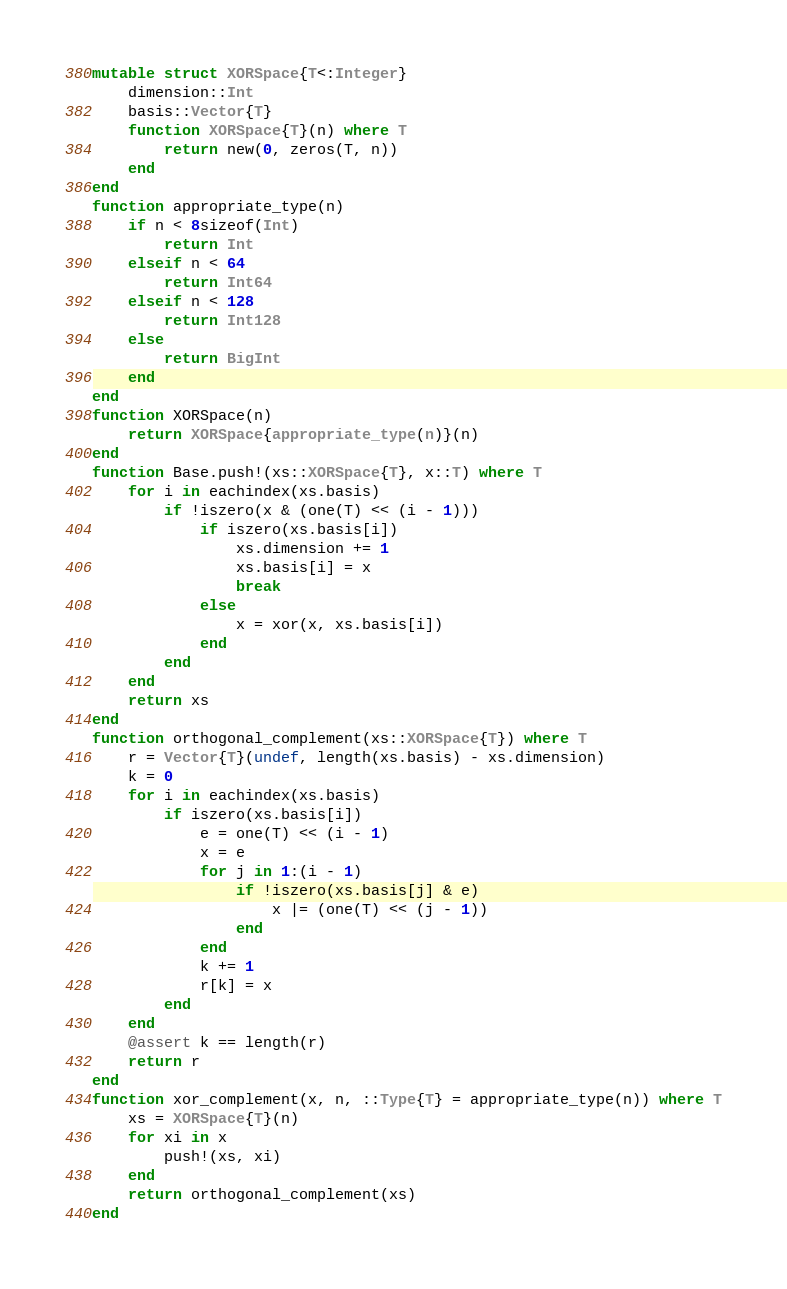<code> <loc_0><loc_0><loc_500><loc_500><_Julia_>mutable struct XORSpace{T<:Integer}
    dimension::Int
    basis::Vector{T}
    function XORSpace{T}(n) where T
        return new(0, zeros(T, n))
    end
end
function appropriate_type(n)
    if n < 8sizeof(Int)
        return Int
    elseif n < 64
        return Int64
    elseif n < 128
        return Int128
    else
        return BigInt
    end
end
function XORSpace(n)
    return XORSpace{appropriate_type(n)}(n)
end
function Base.push!(xs::XORSpace{T}, x::T) where T
    for i in eachindex(xs.basis)
        if !iszero(x & (one(T) << (i - 1)))
            if iszero(xs.basis[i])
                xs.dimension += 1
                xs.basis[i] = x
                break
            else
                x = xor(x, xs.basis[i])
            end
        end
    end
    return xs
end
function orthogonal_complement(xs::XORSpace{T}) where T
    r = Vector{T}(undef, length(xs.basis) - xs.dimension)
    k = 0
    for i in eachindex(xs.basis)
        if iszero(xs.basis[i])
            e = one(T) << (i - 1)
            x = e
            for j in 1:(i - 1)
                if !iszero(xs.basis[j] & e)
                    x |= (one(T) << (j - 1))
                end
            end
            k += 1
            r[k] = x
        end
    end
    @assert k == length(r)
    return r
end
function xor_complement(x, n, ::Type{T} = appropriate_type(n)) where T
    xs = XORSpace{T}(n)
    for xi in x
        push!(xs, xi)
    end
    return orthogonal_complement(xs)
end
</code> 